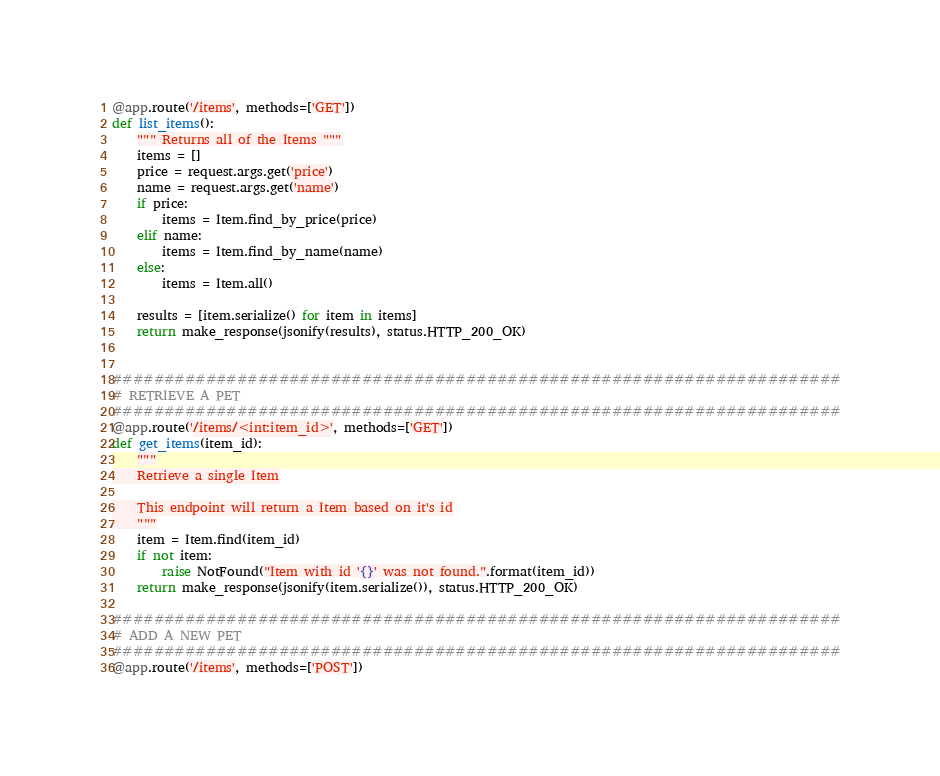Convert code to text. <code><loc_0><loc_0><loc_500><loc_500><_Python_>@app.route('/items', methods=['GET'])
def list_items():
    """ Returns all of the Items """
    items = []
    price = request.args.get('price')
    name = request.args.get('name')
    if price:
        items = Item.find_by_price(price)
    elif name:
        items = Item.find_by_name(name)
    else:
        items = Item.all()

    results = [item.serialize() for item in items]
    return make_response(jsonify(results), status.HTTP_200_OK)


######################################################################
# RETRIEVE A PET
######################################################################
@app.route('/items/<int:item_id>', methods=['GET'])
def get_items(item_id):
    """
    Retrieve a single Item

    This endpoint will return a Item based on it's id
    """
    item = Item.find(item_id)
    if not item:
        raise NotFound("Item with id '{}' was not found.".format(item_id))
    return make_response(jsonify(item.serialize()), status.HTTP_200_OK)

######################################################################
# ADD A NEW PET
######################################################################
@app.route('/items', methods=['POST'])</code> 